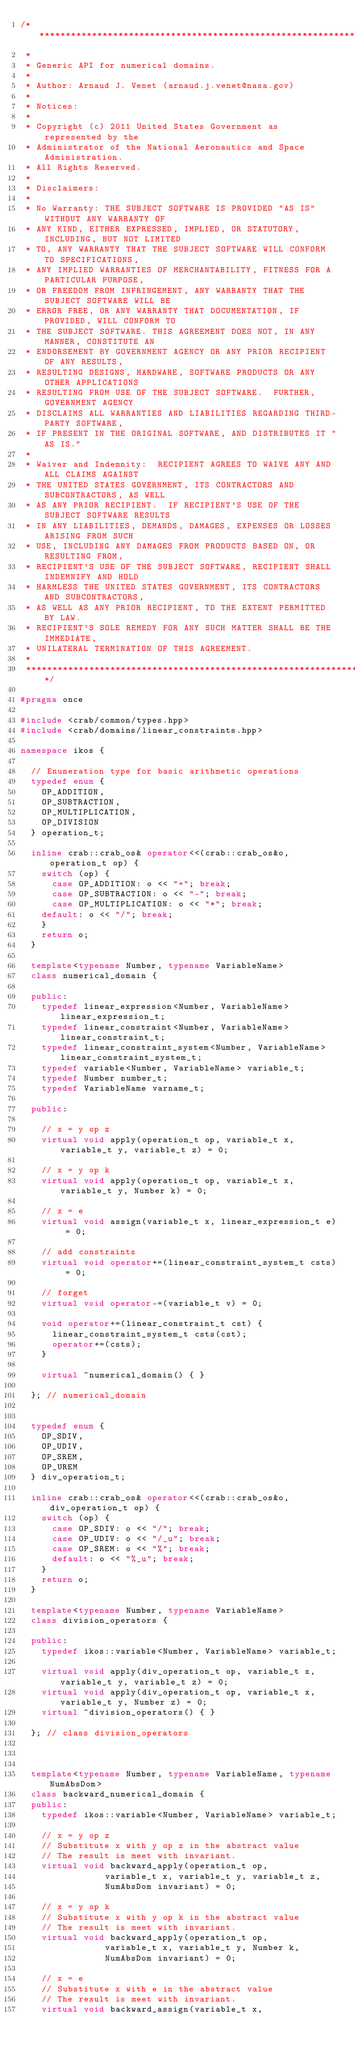Convert code to text. <code><loc_0><loc_0><loc_500><loc_500><_C++_>/*******************************************************************************
 *
 * Generic API for numerical domains.
 *
 * Author: Arnaud J. Venet (arnaud.j.venet@nasa.gov)
 *
 * Notices:
 *
 * Copyright (c) 2011 United States Government as represented by the
 * Administrator of the National Aeronautics and Space Administration.
 * All Rights Reserved.
 *
 * Disclaimers:
 *
 * No Warranty: THE SUBJECT SOFTWARE IS PROVIDED "AS IS" WITHOUT ANY WARRANTY OF
 * ANY KIND, EITHER EXPRESSED, IMPLIED, OR STATUTORY, INCLUDING, BUT NOT LIMITED
 * TO, ANY WARRANTY THAT THE SUBJECT SOFTWARE WILL CONFORM TO SPECIFICATIONS,
 * ANY IMPLIED WARRANTIES OF MERCHANTABILITY, FITNESS FOR A PARTICULAR PURPOSE,
 * OR FREEDOM FROM INFRINGEMENT, ANY WARRANTY THAT THE SUBJECT SOFTWARE WILL BE
 * ERROR FREE, OR ANY WARRANTY THAT DOCUMENTATION, IF PROVIDED, WILL CONFORM TO
 * THE SUBJECT SOFTWARE. THIS AGREEMENT DOES NOT, IN ANY MANNER, CONSTITUTE AN
 * ENDORSEMENT BY GOVERNMENT AGENCY OR ANY PRIOR RECIPIENT OF ANY RESULTS,
 * RESULTING DESIGNS, HARDWARE, SOFTWARE PRODUCTS OR ANY OTHER APPLICATIONS
 * RESULTING FROM USE OF THE SUBJECT SOFTWARE.  FURTHER, GOVERNMENT AGENCY
 * DISCLAIMS ALL WARRANTIES AND LIABILITIES REGARDING THIRD-PARTY SOFTWARE,
 * IF PRESENT IN THE ORIGINAL SOFTWARE, AND DISTRIBUTES IT "AS IS."
 *
 * Waiver and Indemnity:  RECIPIENT AGREES TO WAIVE ANY AND ALL CLAIMS AGAINST
 * THE UNITED STATES GOVERNMENT, ITS CONTRACTORS AND SUBCONTRACTORS, AS WELL
 * AS ANY PRIOR RECIPIENT.  IF RECIPIENT'S USE OF THE SUBJECT SOFTWARE RESULTS
 * IN ANY LIABILITIES, DEMANDS, DAMAGES, EXPENSES OR LOSSES ARISING FROM SUCH
 * USE, INCLUDING ANY DAMAGES FROM PRODUCTS BASED ON, OR RESULTING FROM,
 * RECIPIENT'S USE OF THE SUBJECT SOFTWARE, RECIPIENT SHALL INDEMNIFY AND HOLD
 * HARMLESS THE UNITED STATES GOVERNMENT, ITS CONTRACTORS AND SUBCONTRACTORS,
 * AS WELL AS ANY PRIOR RECIPIENT, TO THE EXTENT PERMITTED BY LAW.
 * RECIPIENT'S SOLE REMEDY FOR ANY SUCH MATTER SHALL BE THE IMMEDIATE,
 * UNILATERAL TERMINATION OF THIS AGREEMENT.
 *
 ******************************************************************************/

#pragma once

#include <crab/common/types.hpp>
#include <crab/domains/linear_constraints.hpp>

namespace ikos {

  // Enumeration type for basic arithmetic operations
  typedef enum {
    OP_ADDITION,
    OP_SUBTRACTION,
    OP_MULTIPLICATION,
    OP_DIVISION
  } operation_t;

  inline crab::crab_os& operator<<(crab::crab_os&o, operation_t op) {
    switch (op) {
      case OP_ADDITION: o << "+"; break;
      case OP_SUBTRACTION: o << "-"; break;
      case OP_MULTIPLICATION: o << "*"; break;
    default: o << "/"; break;
    }
    return o;
  }
  
  template<typename Number, typename VariableName>
  class numerical_domain {
    
  public:
    typedef linear_expression<Number, VariableName> linear_expression_t;
    typedef linear_constraint<Number, VariableName> linear_constraint_t;
    typedef linear_constraint_system<Number, VariableName> linear_constraint_system_t;
    typedef variable<Number, VariableName> variable_t;
    typedef Number number_t;
    typedef VariableName varname_t;
    
  public:
    
    // x = y op z    
    virtual void apply(operation_t op, variable_t x, variable_t y, variable_t z) = 0; 

    // x = y op k    
    virtual void apply(operation_t op, variable_t x, variable_t y, Number k) = 0; 

    // x = e    
    virtual void assign(variable_t x, linear_expression_t e) = 0; 

    // add constraints
    virtual void operator+=(linear_constraint_system_t csts) = 0;

    // forget
    virtual void operator-=(variable_t v) = 0;

    void operator+=(linear_constraint_t cst) {
      linear_constraint_system_t csts(cst);
      operator+=(csts);
    }

    virtual ~numerical_domain() { }
    
  }; // numerical_domain


  typedef enum { 
    OP_SDIV, 
    OP_UDIV, 
    OP_SREM, 
    OP_UREM
  } div_operation_t;

  inline crab::crab_os& operator<<(crab::crab_os&o, div_operation_t op) {
    switch (op) {
      case OP_SDIV: o << "/"; break;
      case OP_UDIV: o << "/_u"; break;
      case OP_SREM: o << "%"; break;
      default: o << "%_u"; break;
    }
    return o;
  }

  template<typename Number, typename VariableName>
  class division_operators {

  public:
    typedef ikos::variable<Number, VariableName> variable_t;
    
    virtual void apply(div_operation_t op, variable_t x, variable_t y, variable_t z) = 0;
    virtual void apply(div_operation_t op, variable_t x, variable_t y, Number z) = 0;
    virtual ~division_operators() { }

  }; // class division_operators
  

  
  template<typename Number, typename VariableName, typename NumAbsDom>
  class backward_numerical_domain {
  public:
    typedef ikos::variable<Number, VariableName> variable_t;
    
    // x = y op z
    // Substitute x with y op z in the abstract value
    // The result is meet with invariant.
    virtual void backward_apply(operation_t op,
				variable_t x, variable_t y, variable_t z,
				NumAbsDom invariant) = 0; 

    // x = y op k
    // Substitute x with y op k in the abstract value
    // The result is meet with invariant.    
    virtual void backward_apply(operation_t op,
				variable_t x, variable_t y, Number k,
				NumAbsDom invariant) = 0; 

    // x = e
    // Substitute x with e in the abstract value
    // The result is meet with invariant.    
    virtual void backward_assign(variable_t x,</code> 